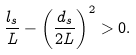<formula> <loc_0><loc_0><loc_500><loc_500>\frac { l _ { s } } { L } - \left ( \frac { d _ { s } } { 2 L } \right ) ^ { 2 } > 0 .</formula> 